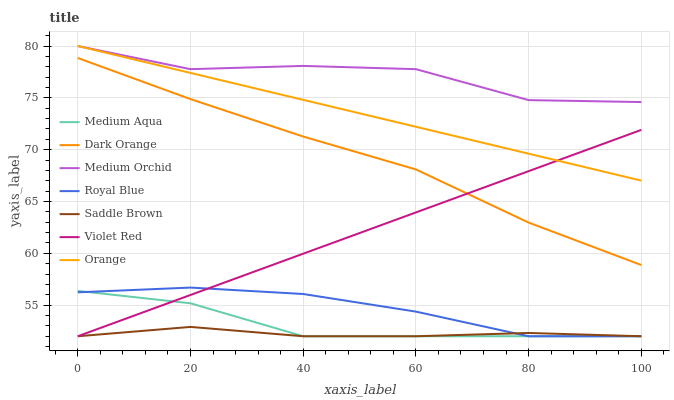Does Saddle Brown have the minimum area under the curve?
Answer yes or no. Yes. Does Medium Orchid have the maximum area under the curve?
Answer yes or no. Yes. Does Violet Red have the minimum area under the curve?
Answer yes or no. No. Does Violet Red have the maximum area under the curve?
Answer yes or no. No. Is Violet Red the smoothest?
Answer yes or no. Yes. Is Medium Orchid the roughest?
Answer yes or no. Yes. Is Medium Orchid the smoothest?
Answer yes or no. No. Is Violet Red the roughest?
Answer yes or no. No. Does Medium Orchid have the lowest value?
Answer yes or no. No. Does Orange have the highest value?
Answer yes or no. Yes. Does Violet Red have the highest value?
Answer yes or no. No. Is Dark Orange less than Orange?
Answer yes or no. Yes. Is Dark Orange greater than Royal Blue?
Answer yes or no. Yes. Does Royal Blue intersect Violet Red?
Answer yes or no. Yes. Is Royal Blue less than Violet Red?
Answer yes or no. No. Is Royal Blue greater than Violet Red?
Answer yes or no. No. Does Dark Orange intersect Orange?
Answer yes or no. No. 